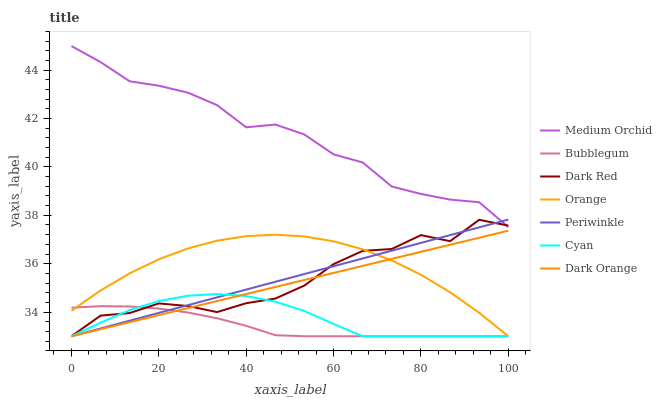Does Bubblegum have the minimum area under the curve?
Answer yes or no. Yes. Does Medium Orchid have the maximum area under the curve?
Answer yes or no. Yes. Does Dark Red have the minimum area under the curve?
Answer yes or no. No. Does Dark Red have the maximum area under the curve?
Answer yes or no. No. Is Periwinkle the smoothest?
Answer yes or no. Yes. Is Dark Red the roughest?
Answer yes or no. Yes. Is Medium Orchid the smoothest?
Answer yes or no. No. Is Medium Orchid the roughest?
Answer yes or no. No. Does Dark Orange have the lowest value?
Answer yes or no. Yes. Does Medium Orchid have the lowest value?
Answer yes or no. No. Does Medium Orchid have the highest value?
Answer yes or no. Yes. Does Dark Red have the highest value?
Answer yes or no. No. Is Bubblegum less than Medium Orchid?
Answer yes or no. Yes. Is Medium Orchid greater than Cyan?
Answer yes or no. Yes. Does Periwinkle intersect Dark Orange?
Answer yes or no. Yes. Is Periwinkle less than Dark Orange?
Answer yes or no. No. Is Periwinkle greater than Dark Orange?
Answer yes or no. No. Does Bubblegum intersect Medium Orchid?
Answer yes or no. No. 